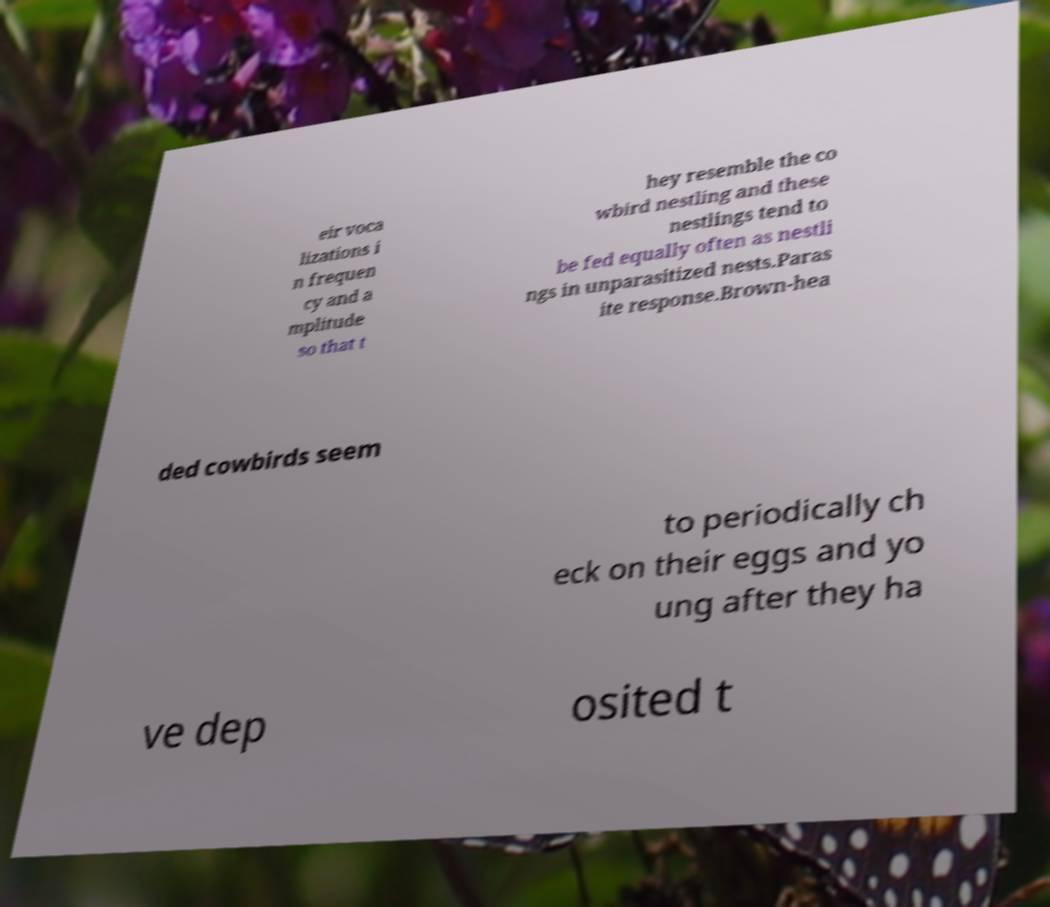Could you assist in decoding the text presented in this image and type it out clearly? eir voca lizations i n frequen cy and a mplitude so that t hey resemble the co wbird nestling and these nestlings tend to be fed equally often as nestli ngs in unparasitized nests.Paras ite response.Brown-hea ded cowbirds seem to periodically ch eck on their eggs and yo ung after they ha ve dep osited t 